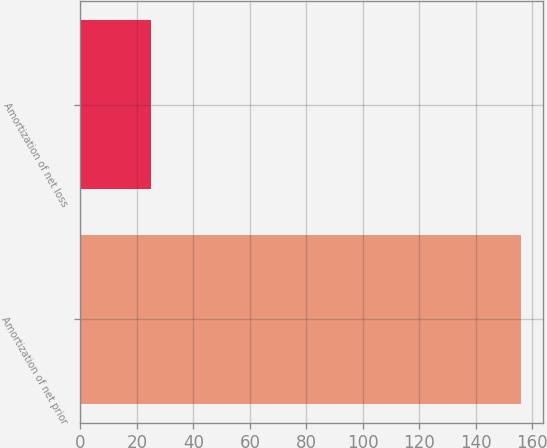<chart> <loc_0><loc_0><loc_500><loc_500><bar_chart><fcel>Amortization of net prior<fcel>Amortization of net loss<nl><fcel>156<fcel>25<nl></chart> 